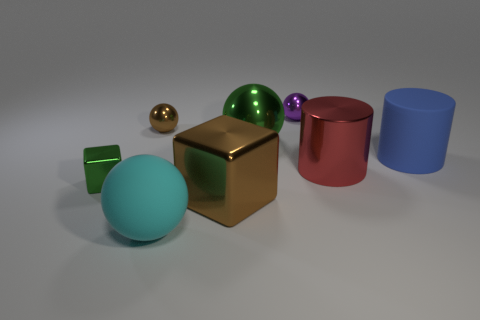Is the green thing that is behind the green metallic cube made of the same material as the green block?
Offer a terse response. Yes. What number of other things are the same size as the purple thing?
Keep it short and to the point. 2. How many big things are shiny cylinders or green balls?
Your response must be concise. 2. Do the small shiny cube and the large rubber cylinder have the same color?
Give a very brief answer. No. Is the number of tiny things in front of the big red metal cylinder greater than the number of big brown blocks that are on the right side of the big cyan object?
Provide a short and direct response. No. There is a big cylinder behind the red shiny thing; is it the same color as the large matte sphere?
Offer a very short reply. No. Is there anything else that is the same color as the matte ball?
Provide a short and direct response. No. Is the number of big cyan spheres that are to the left of the tiny green block greater than the number of large objects?
Keep it short and to the point. No. Is the purple metal sphere the same size as the blue cylinder?
Make the answer very short. No. There is a tiny purple object that is the same shape as the cyan object; what material is it?
Make the answer very short. Metal. 